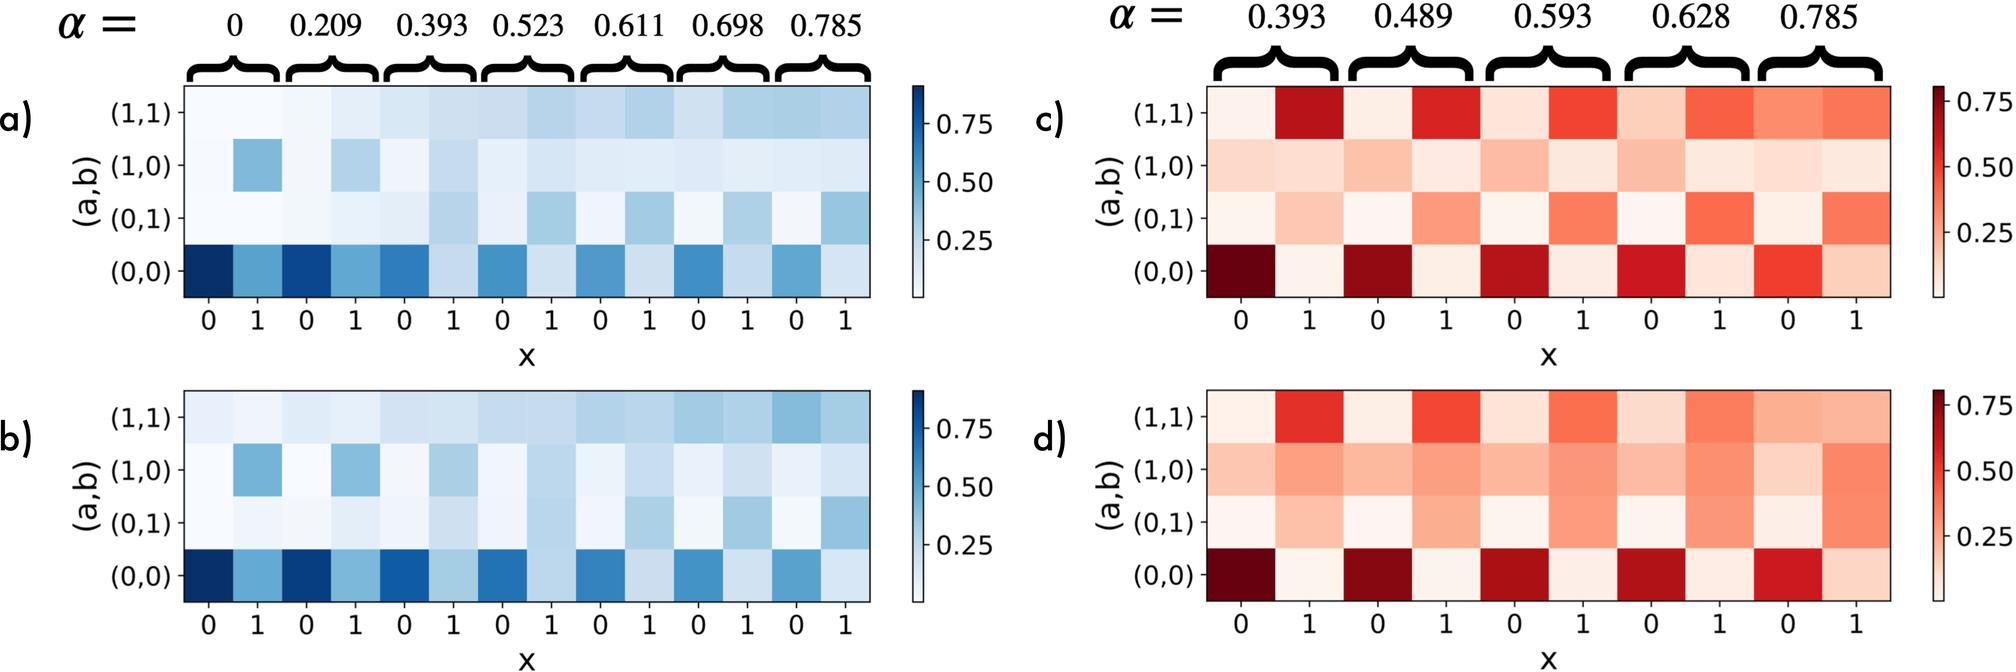Could you explain why the heatmaps use different colors to represent correlations? The heatmaps use variations in color to visually represent different levels of correlation coefficients. Typically, heatmaps apply a color gradient; darker or more intense colors indicate higher correlation values and lighter colors indicate lower ones. This method simplifies understanding patterns in data by providing a clear, visual differentiation of value ranges, which helps in quickly identifying areas of interest or concern in studies of relationships between variables. 